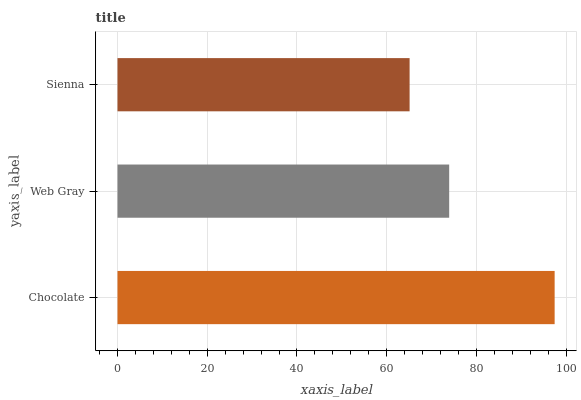Is Sienna the minimum?
Answer yes or no. Yes. Is Chocolate the maximum?
Answer yes or no. Yes. Is Web Gray the minimum?
Answer yes or no. No. Is Web Gray the maximum?
Answer yes or no. No. Is Chocolate greater than Web Gray?
Answer yes or no. Yes. Is Web Gray less than Chocolate?
Answer yes or no. Yes. Is Web Gray greater than Chocolate?
Answer yes or no. No. Is Chocolate less than Web Gray?
Answer yes or no. No. Is Web Gray the high median?
Answer yes or no. Yes. Is Web Gray the low median?
Answer yes or no. Yes. Is Chocolate the high median?
Answer yes or no. No. Is Chocolate the low median?
Answer yes or no. No. 